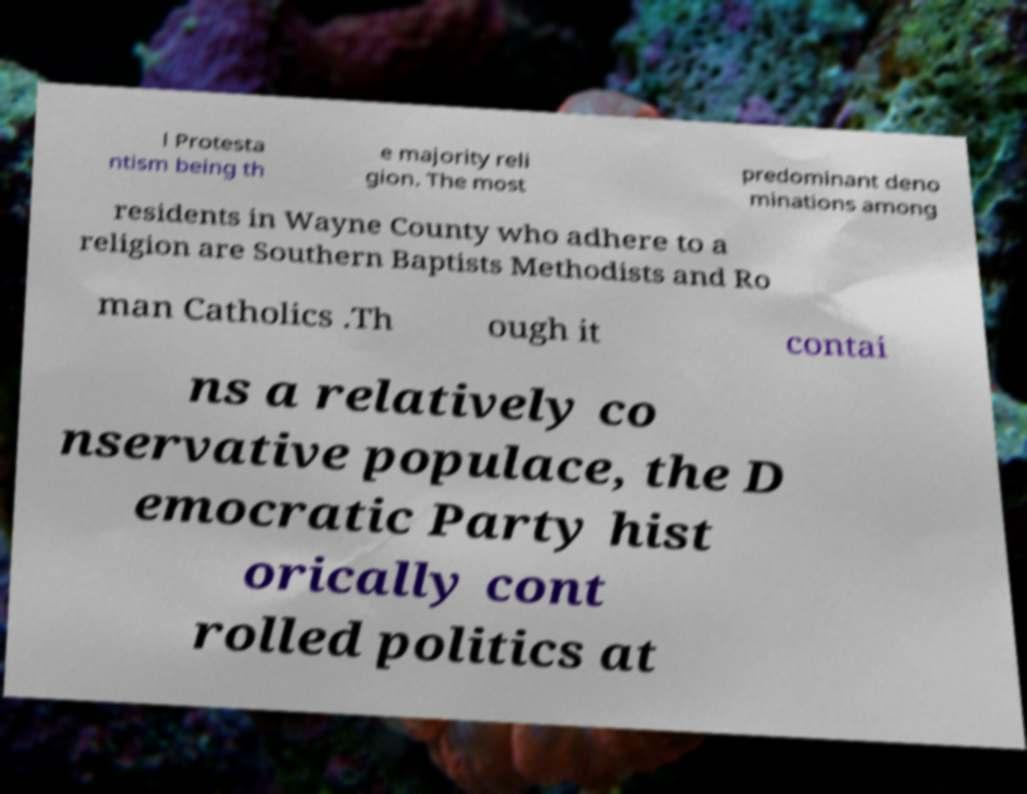Please identify and transcribe the text found in this image. l Protesta ntism being th e majority reli gion. The most predominant deno minations among residents in Wayne County who adhere to a religion are Southern Baptists Methodists and Ro man Catholics .Th ough it contai ns a relatively co nservative populace, the D emocratic Party hist orically cont rolled politics at 